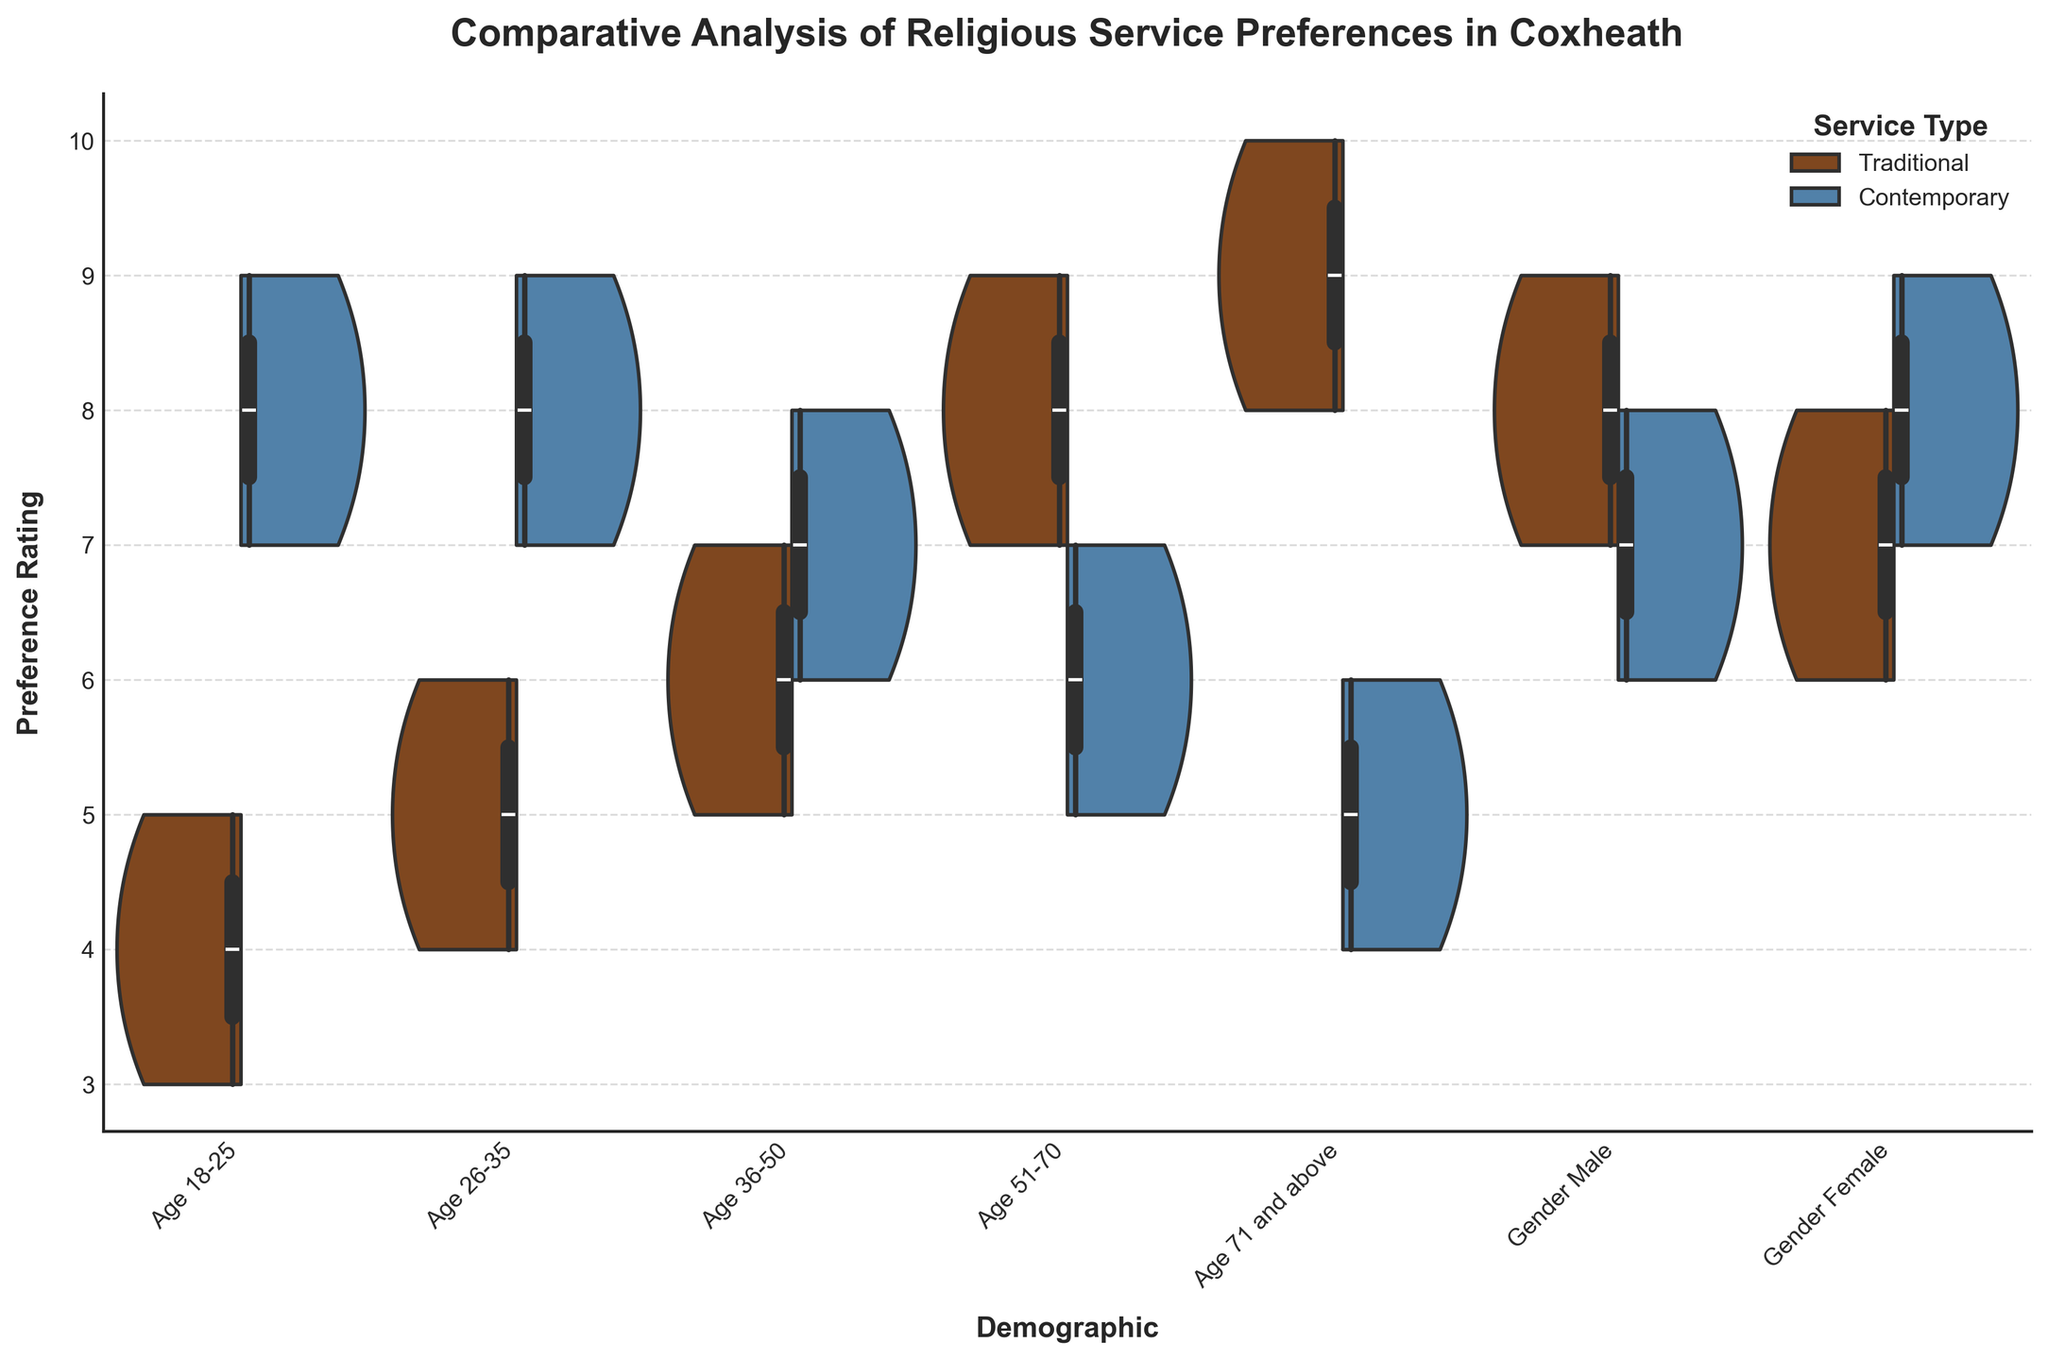What is the title of the figure? The title is located at the top center of the figure. It summarizes the main comparison being made in the chart.
Answer: Comparative Analysis of Religious Service Preferences in Coxheath What are the demographic groups represented along the x-axis? The demographic groups are listed along the x-axis, each representing a different segment of the population.
Answer: Age 18-25, Age 26-35, Age 36-50, Age 51-70, Age 71 and above, Gender Male, Gender Female How is the preference rating for Traditional and Contemporary services visually distinguished in the chart? The preference ratings are distinguished by different colors and are separate but interleaved within each demographic group's violin plot.
Answer: Traditional: brown; Contemporary: blue For the Age 18-25 demographic, which service type has a higher median preference rating? The median is indicated by the white dot within the violin plot and box plot overlay.
Answer: Contemporary Which demographic group shows the highest preference rating for Traditional services? This can be discerned by noticing which group's violin plot extends highest on the y-axis for Traditional services.
Answer: Age 71 and above How do the preference ratings of Contemporary services compare between the Age 26-35 and Age 51-70 demographics? Compare the height and spread of the violin plots of Contemporary services between these demographics.
Answer: Age 26-35 has higher ratings What's the range of preference ratings for Traditional services in the Age 51-70 demographic? The range can be observed directly from the limits of the violin plot and box plot overlay for that demographic.
Answer: 7 to 9 Are there any demographics where the preference ratings for both Traditional and Contemporary services show similar spread and median? Look for demographics where the violin plots and box plots for Traditional and Contemporary services are similar in shape, spread, and median.
Answer: Age 36-50 Which service type shows a wider spread of preference ratings for the Gender Male demographic? Compare the widths of the violin plots for both services within the Gender Male group.
Answer: Contemporary For which demographic group is the median preference rating for each service type closest to each other? Compare the median preference ratings (white dots) for each service type across all demographic groups to find the closest pair.
Answer: Age 36-50 